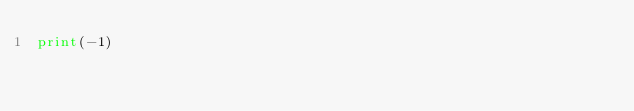<code> <loc_0><loc_0><loc_500><loc_500><_Python_>print(-1)</code> 